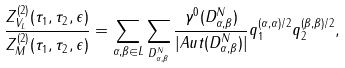<formula> <loc_0><loc_0><loc_500><loc_500>\frac { Z _ { V _ { L } } ^ { ( 2 ) } ( \tau _ { 1 } , \tau _ { 2 } , \epsilon ) } { Z _ { M } ^ { ( 2 ) } ( \tau _ { 1 } , \tau _ { 2 } , \epsilon ) } = \sum _ { \alpha , \beta \in L } \sum _ { D _ { \alpha , \beta } ^ { N } } \frac { \gamma ^ { 0 } ( D _ { \alpha , \beta } ^ { N } ) } { | A u t ( D _ { \alpha , \beta } ^ { N } ) | } q _ { 1 } ^ { ( \alpha , \alpha ) / 2 } q _ { 2 } ^ { ( \beta , \beta ) / 2 } ,</formula> 